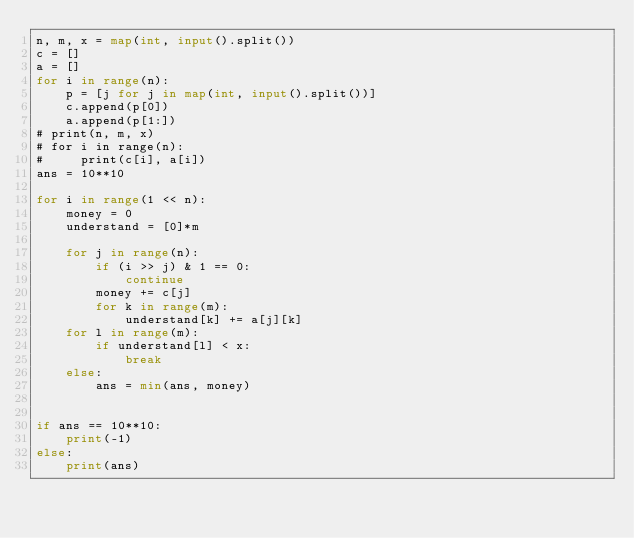Convert code to text. <code><loc_0><loc_0><loc_500><loc_500><_Python_>n, m, x = map(int, input().split())
c = []
a = []
for i in range(n):
    p = [j for j in map(int, input().split())]
    c.append(p[0])
    a.append(p[1:])
# print(n, m, x)
# for i in range(n):
#     print(c[i], a[i])
ans = 10**10

for i in range(1 << n):
    money = 0
    understand = [0]*m

    for j in range(n):
        if (i >> j) & 1 == 0:
            continue
        money += c[j]
        for k in range(m):
            understand[k] += a[j][k]
    for l in range(m):
        if understand[l] < x:
            break
    else:
        ans = min(ans, money)


if ans == 10**10:
    print(-1)
else:
    print(ans)
</code> 